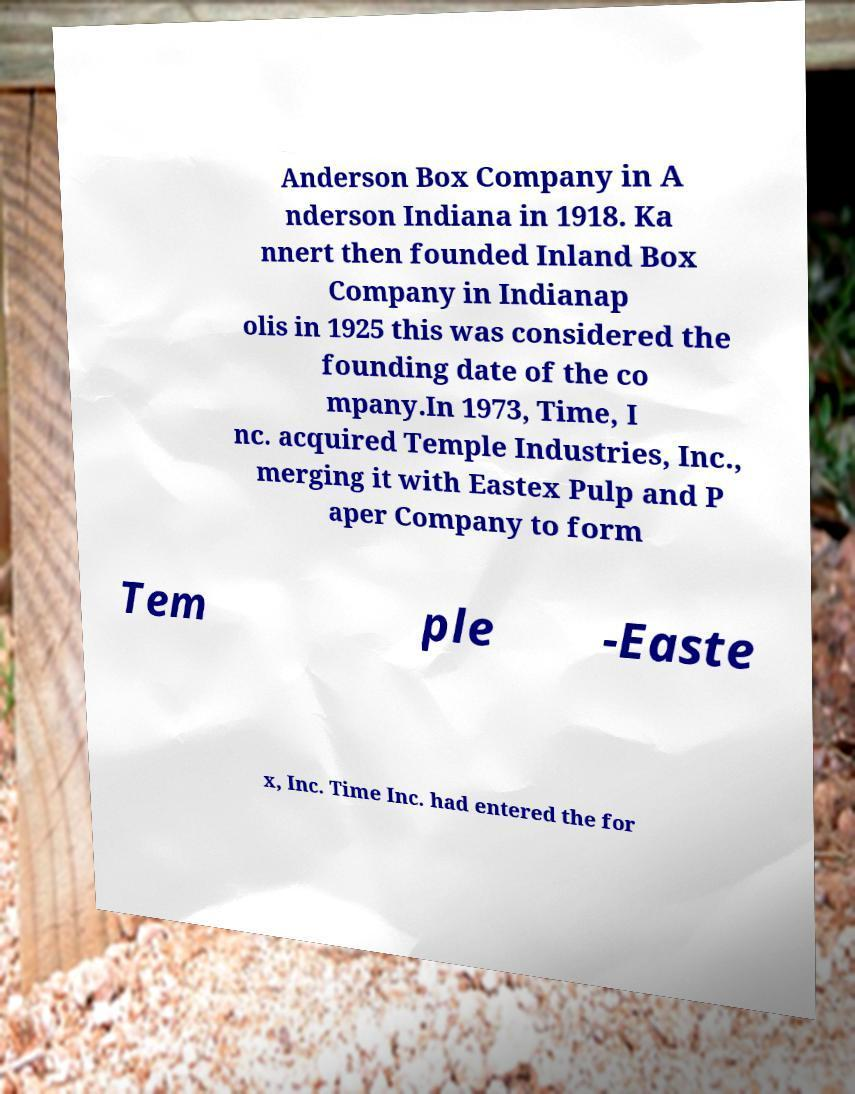Could you extract and type out the text from this image? Anderson Box Company in A nderson Indiana in 1918. Ka nnert then founded Inland Box Company in Indianap olis in 1925 this was considered the founding date of the co mpany.In 1973, Time, I nc. acquired Temple Industries, Inc., merging it with Eastex Pulp and P aper Company to form Tem ple -Easte x, Inc. Time Inc. had entered the for 